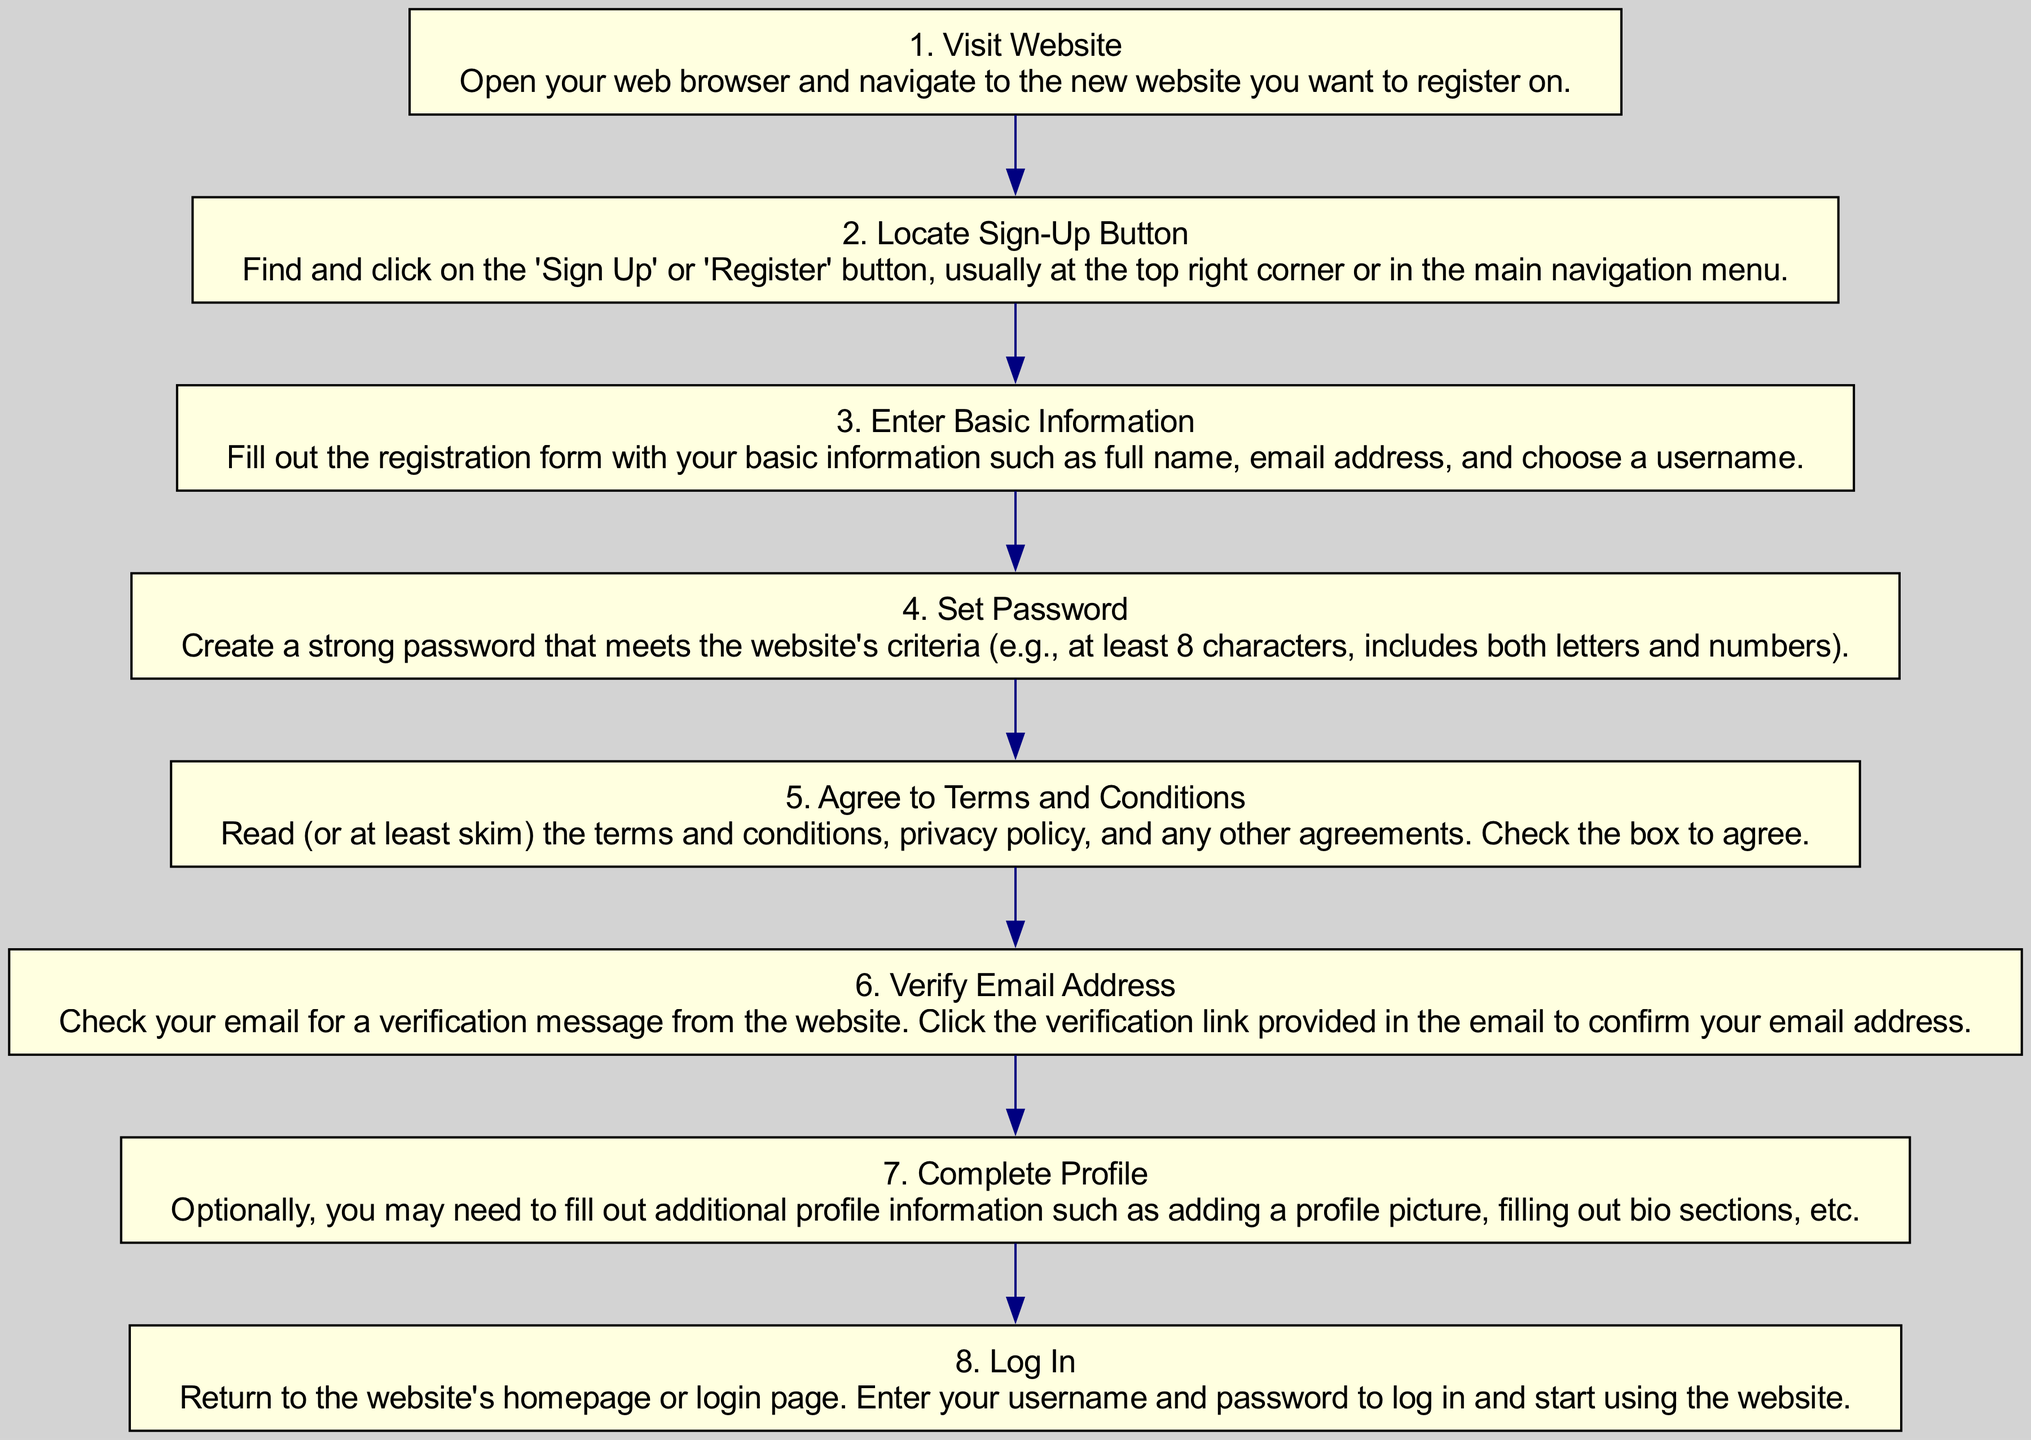What is the first step in the registration process? The diagram begins with the initial node labeled "1. Visit Website," indicating that visiting the website is the first step before any other actions can be taken.
Answer: Visit Website How many steps are in the registration process? By counting the nodes in the diagram, there are a total of eight steps illustrated, from visiting the website to logging in.
Answer: 8 What is required after entering basic information? The flow chart indicates that after the "Enter Basic Information" step, users must "Set Password" in the next step, which is necessary to continue the registration process.
Answer: Set Password Which step involves confirming your email? The step labeled "6. Verify Email Address" specifically describes the action of checking your email for a verification message to confirm your email address.
Answer: Verify Email Address What action follows agreeing to terms and conditions? Referring to the flow of the chart, after agreeing to the terms and conditions, the next action specified is to "Verify Email Address." This indicates that verification comes after agreeing to the agreements.
Answer: Verify Email Address Which step is optional in the registration process? The diagram highlights "7. Complete Profile" as an optional step, suggesting that users can enhance their profiles after logging in but it is not mandatory for initial registration.
Answer: Complete Profile What do you need to do to start using the website after registration? To start using the website after completing the registration process, you must "Log In," which is indicated as the final step in the flow of the chart.
Answer: Log In How does the registration process conclude? The flow chart ends with the action of "Log In," which signifies that following all the previous steps, the registration process concludes with the user logging into their account.
Answer: Log In 